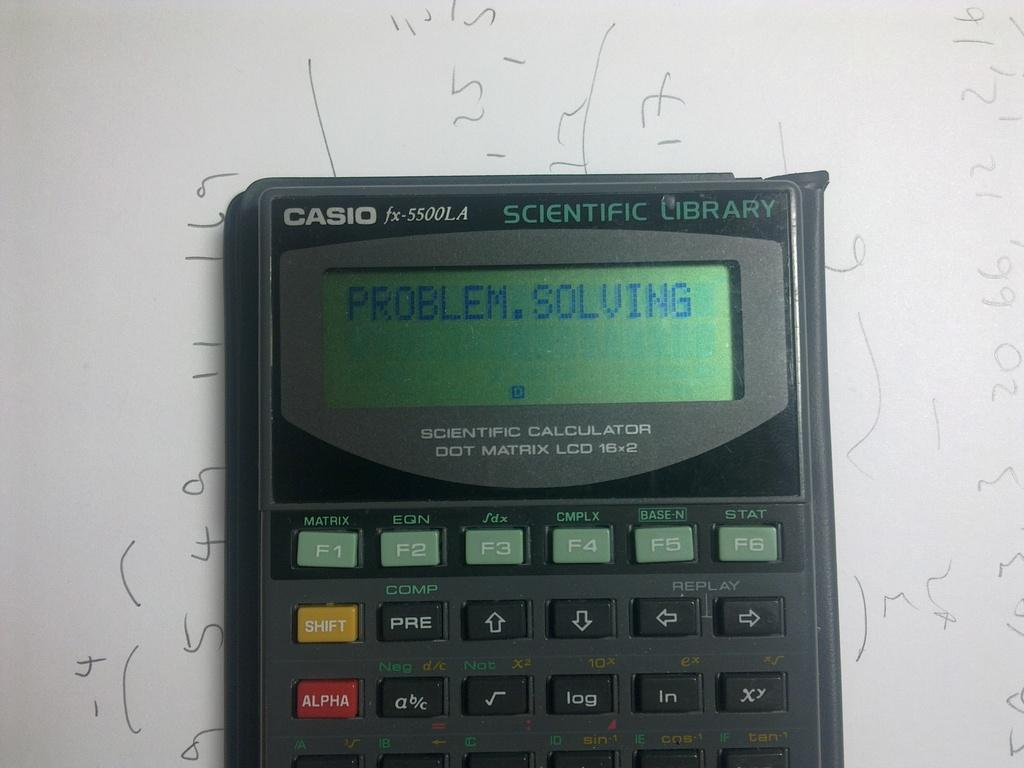<image>
Relay a brief, clear account of the picture shown. A Casio calculator reads "PROBLEM.SOLVING" on top of a piece of paper. 